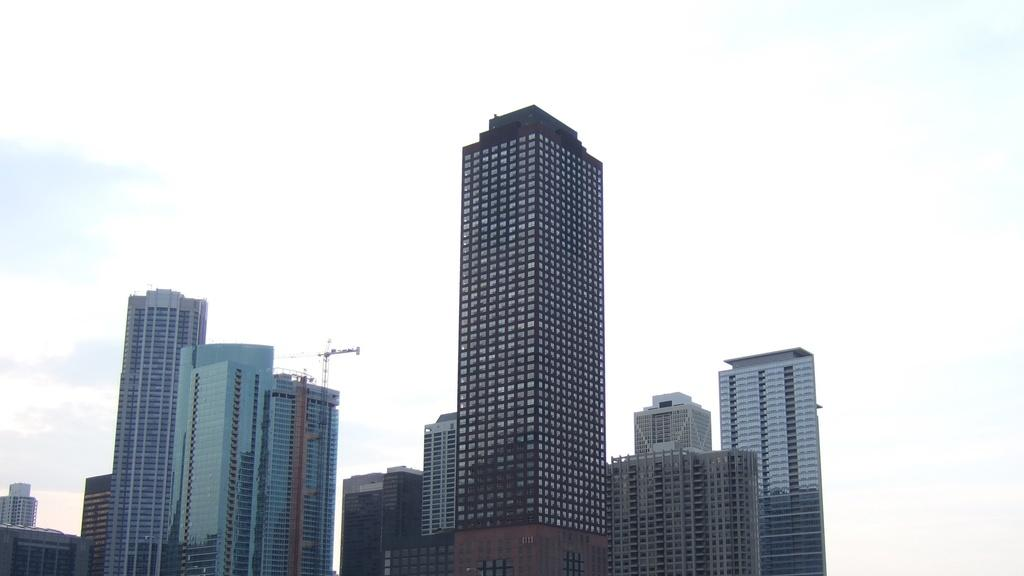What types of structures can be seen in the image? There are multiple buildings in the image. What part of the natural environment is visible in the image? The sky is visible in the image. What trick can be seen being performed in the image? There is no trick being performed in the image; it simply shows multiple buildings and the sky. 